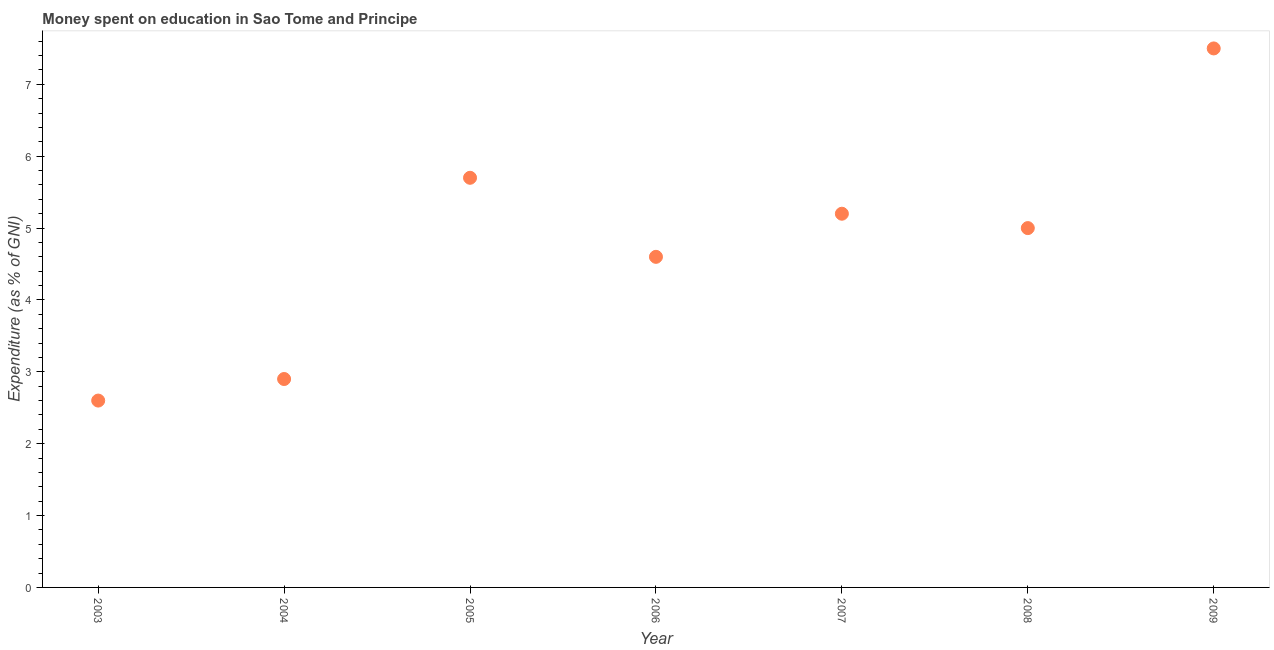What is the expenditure on education in 2003?
Your response must be concise. 2.6. What is the sum of the expenditure on education?
Your answer should be compact. 33.5. What is the difference between the expenditure on education in 2004 and 2008?
Give a very brief answer. -2.1. What is the average expenditure on education per year?
Your answer should be compact. 4.79. What is the median expenditure on education?
Your answer should be compact. 5. In how many years, is the expenditure on education greater than 7.4 %?
Your response must be concise. 1. What is the ratio of the expenditure on education in 2003 to that in 2004?
Provide a short and direct response. 0.9. Is the expenditure on education in 2004 less than that in 2009?
Your response must be concise. Yes. What is the difference between the highest and the second highest expenditure on education?
Your answer should be compact. 1.8. Is the sum of the expenditure on education in 2003 and 2007 greater than the maximum expenditure on education across all years?
Your answer should be compact. Yes. How many dotlines are there?
Give a very brief answer. 1. What is the difference between two consecutive major ticks on the Y-axis?
Provide a succinct answer. 1. Are the values on the major ticks of Y-axis written in scientific E-notation?
Offer a very short reply. No. What is the title of the graph?
Your response must be concise. Money spent on education in Sao Tome and Principe. What is the label or title of the X-axis?
Make the answer very short. Year. What is the label or title of the Y-axis?
Offer a terse response. Expenditure (as % of GNI). What is the Expenditure (as % of GNI) in 2003?
Provide a succinct answer. 2.6. What is the Expenditure (as % of GNI) in 2004?
Provide a succinct answer. 2.9. What is the Expenditure (as % of GNI) in 2006?
Give a very brief answer. 4.6. What is the difference between the Expenditure (as % of GNI) in 2003 and 2004?
Ensure brevity in your answer.  -0.3. What is the difference between the Expenditure (as % of GNI) in 2004 and 2005?
Give a very brief answer. -2.8. What is the difference between the Expenditure (as % of GNI) in 2004 and 2007?
Make the answer very short. -2.3. What is the difference between the Expenditure (as % of GNI) in 2006 and 2007?
Your answer should be compact. -0.6. What is the difference between the Expenditure (as % of GNI) in 2006 and 2008?
Keep it short and to the point. -0.4. What is the difference between the Expenditure (as % of GNI) in 2008 and 2009?
Your response must be concise. -2.5. What is the ratio of the Expenditure (as % of GNI) in 2003 to that in 2004?
Provide a succinct answer. 0.9. What is the ratio of the Expenditure (as % of GNI) in 2003 to that in 2005?
Offer a terse response. 0.46. What is the ratio of the Expenditure (as % of GNI) in 2003 to that in 2006?
Provide a short and direct response. 0.56. What is the ratio of the Expenditure (as % of GNI) in 2003 to that in 2007?
Your answer should be compact. 0.5. What is the ratio of the Expenditure (as % of GNI) in 2003 to that in 2008?
Give a very brief answer. 0.52. What is the ratio of the Expenditure (as % of GNI) in 2003 to that in 2009?
Your response must be concise. 0.35. What is the ratio of the Expenditure (as % of GNI) in 2004 to that in 2005?
Provide a short and direct response. 0.51. What is the ratio of the Expenditure (as % of GNI) in 2004 to that in 2006?
Your answer should be compact. 0.63. What is the ratio of the Expenditure (as % of GNI) in 2004 to that in 2007?
Offer a very short reply. 0.56. What is the ratio of the Expenditure (as % of GNI) in 2004 to that in 2008?
Offer a terse response. 0.58. What is the ratio of the Expenditure (as % of GNI) in 2004 to that in 2009?
Ensure brevity in your answer.  0.39. What is the ratio of the Expenditure (as % of GNI) in 2005 to that in 2006?
Give a very brief answer. 1.24. What is the ratio of the Expenditure (as % of GNI) in 2005 to that in 2007?
Offer a terse response. 1.1. What is the ratio of the Expenditure (as % of GNI) in 2005 to that in 2008?
Provide a short and direct response. 1.14. What is the ratio of the Expenditure (as % of GNI) in 2005 to that in 2009?
Keep it short and to the point. 0.76. What is the ratio of the Expenditure (as % of GNI) in 2006 to that in 2007?
Keep it short and to the point. 0.89. What is the ratio of the Expenditure (as % of GNI) in 2006 to that in 2008?
Offer a very short reply. 0.92. What is the ratio of the Expenditure (as % of GNI) in 2006 to that in 2009?
Your answer should be very brief. 0.61. What is the ratio of the Expenditure (as % of GNI) in 2007 to that in 2008?
Provide a short and direct response. 1.04. What is the ratio of the Expenditure (as % of GNI) in 2007 to that in 2009?
Offer a very short reply. 0.69. What is the ratio of the Expenditure (as % of GNI) in 2008 to that in 2009?
Your answer should be compact. 0.67. 